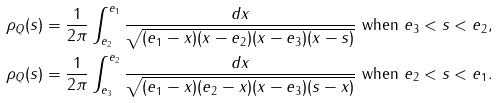Convert formula to latex. <formula><loc_0><loc_0><loc_500><loc_500>\rho _ { Q } ( s ) & = \frac { 1 } { 2 \pi } \int _ { e _ { 2 } } ^ { e _ { 1 } } \frac { d x } { \sqrt { ( e _ { 1 } - x ) ( x - e _ { 2 } ) ( x - e _ { 3 } ) ( x - s ) } } \text { when } e _ { 3 } < s < e _ { 2 } , \\ \rho _ { Q } ( s ) & = \frac { 1 } { 2 \pi } \int _ { e _ { 3 } } ^ { e _ { 2 } } \frac { d x } { \sqrt { ( e _ { 1 } - x ) ( e _ { 2 } - x ) ( x - e _ { 3 } ) ( s - x ) } } \text { when } e _ { 2 } < s < e _ { 1 } .</formula> 